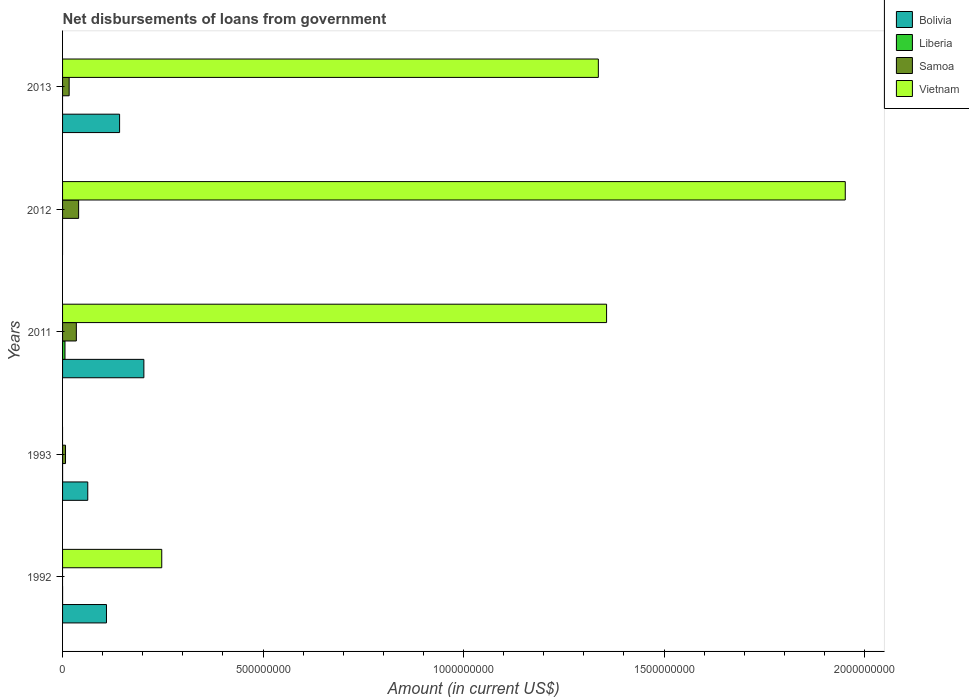How many different coloured bars are there?
Offer a terse response. 4. How many groups of bars are there?
Your answer should be very brief. 5. How many bars are there on the 4th tick from the top?
Give a very brief answer. 3. What is the label of the 1st group of bars from the top?
Your answer should be compact. 2013. What is the amount of loan disbursed from government in Bolivia in 2013?
Offer a very short reply. 1.42e+08. Across all years, what is the maximum amount of loan disbursed from government in Samoa?
Your answer should be very brief. 4.00e+07. What is the total amount of loan disbursed from government in Liberia in the graph?
Offer a very short reply. 6.09e+06. What is the difference between the amount of loan disbursed from government in Bolivia in 1993 and that in 2013?
Your answer should be compact. -7.93e+07. What is the difference between the amount of loan disbursed from government in Vietnam in 1992 and the amount of loan disbursed from government in Bolivia in 2013?
Provide a succinct answer. 1.05e+08. What is the average amount of loan disbursed from government in Bolivia per year?
Your answer should be very brief. 1.03e+08. In the year 2011, what is the difference between the amount of loan disbursed from government in Vietnam and amount of loan disbursed from government in Bolivia?
Your answer should be very brief. 1.15e+09. In how many years, is the amount of loan disbursed from government in Bolivia greater than 1300000000 US$?
Your answer should be very brief. 0. What is the ratio of the amount of loan disbursed from government in Samoa in 2011 to that in 2013?
Your answer should be compact. 2.09. What is the difference between the highest and the second highest amount of loan disbursed from government in Bolivia?
Make the answer very short. 6.06e+07. What is the difference between the highest and the lowest amount of loan disbursed from government in Vietnam?
Your response must be concise. 1.95e+09. In how many years, is the amount of loan disbursed from government in Vietnam greater than the average amount of loan disbursed from government in Vietnam taken over all years?
Give a very brief answer. 3. Is it the case that in every year, the sum of the amount of loan disbursed from government in Liberia and amount of loan disbursed from government in Vietnam is greater than the amount of loan disbursed from government in Bolivia?
Provide a succinct answer. No. Are all the bars in the graph horizontal?
Keep it short and to the point. Yes. How many years are there in the graph?
Offer a terse response. 5. Does the graph contain grids?
Offer a terse response. No. How many legend labels are there?
Ensure brevity in your answer.  4. How are the legend labels stacked?
Your response must be concise. Vertical. What is the title of the graph?
Your response must be concise. Net disbursements of loans from government. Does "Latin America(all income levels)" appear as one of the legend labels in the graph?
Give a very brief answer. No. What is the label or title of the X-axis?
Ensure brevity in your answer.  Amount (in current US$). What is the Amount (in current US$) of Bolivia in 1992?
Provide a succinct answer. 1.09e+08. What is the Amount (in current US$) in Liberia in 1992?
Keep it short and to the point. 2.70e+04. What is the Amount (in current US$) of Samoa in 1992?
Your response must be concise. 0. What is the Amount (in current US$) in Vietnam in 1992?
Offer a terse response. 2.47e+08. What is the Amount (in current US$) of Bolivia in 1993?
Provide a succinct answer. 6.29e+07. What is the Amount (in current US$) in Liberia in 1993?
Your response must be concise. 2.50e+04. What is the Amount (in current US$) of Samoa in 1993?
Keep it short and to the point. 7.37e+06. What is the Amount (in current US$) in Vietnam in 1993?
Provide a succinct answer. 0. What is the Amount (in current US$) of Bolivia in 2011?
Your answer should be very brief. 2.03e+08. What is the Amount (in current US$) in Liberia in 2011?
Your response must be concise. 6.04e+06. What is the Amount (in current US$) of Samoa in 2011?
Your answer should be very brief. 3.44e+07. What is the Amount (in current US$) of Vietnam in 2011?
Offer a very short reply. 1.36e+09. What is the Amount (in current US$) in Bolivia in 2012?
Make the answer very short. 0. What is the Amount (in current US$) in Liberia in 2012?
Your response must be concise. 0. What is the Amount (in current US$) in Samoa in 2012?
Your answer should be compact. 4.00e+07. What is the Amount (in current US$) of Vietnam in 2012?
Your answer should be very brief. 1.95e+09. What is the Amount (in current US$) of Bolivia in 2013?
Ensure brevity in your answer.  1.42e+08. What is the Amount (in current US$) in Samoa in 2013?
Offer a very short reply. 1.65e+07. What is the Amount (in current US$) in Vietnam in 2013?
Offer a very short reply. 1.34e+09. Across all years, what is the maximum Amount (in current US$) of Bolivia?
Make the answer very short. 2.03e+08. Across all years, what is the maximum Amount (in current US$) in Liberia?
Provide a short and direct response. 6.04e+06. Across all years, what is the maximum Amount (in current US$) of Samoa?
Your answer should be very brief. 4.00e+07. Across all years, what is the maximum Amount (in current US$) of Vietnam?
Your answer should be compact. 1.95e+09. Across all years, what is the minimum Amount (in current US$) of Liberia?
Make the answer very short. 0. What is the total Amount (in current US$) of Bolivia in the graph?
Ensure brevity in your answer.  5.17e+08. What is the total Amount (in current US$) of Liberia in the graph?
Keep it short and to the point. 6.09e+06. What is the total Amount (in current US$) in Samoa in the graph?
Make the answer very short. 9.82e+07. What is the total Amount (in current US$) of Vietnam in the graph?
Keep it short and to the point. 4.89e+09. What is the difference between the Amount (in current US$) in Bolivia in 1992 and that in 1993?
Give a very brief answer. 4.66e+07. What is the difference between the Amount (in current US$) in Liberia in 1992 and that in 1993?
Your answer should be very brief. 2000. What is the difference between the Amount (in current US$) in Bolivia in 1992 and that in 2011?
Your response must be concise. -9.33e+07. What is the difference between the Amount (in current US$) in Liberia in 1992 and that in 2011?
Your answer should be compact. -6.01e+06. What is the difference between the Amount (in current US$) of Vietnam in 1992 and that in 2011?
Keep it short and to the point. -1.11e+09. What is the difference between the Amount (in current US$) of Vietnam in 1992 and that in 2012?
Offer a terse response. -1.70e+09. What is the difference between the Amount (in current US$) of Bolivia in 1992 and that in 2013?
Your answer should be very brief. -3.27e+07. What is the difference between the Amount (in current US$) of Vietnam in 1992 and that in 2013?
Make the answer very short. -1.09e+09. What is the difference between the Amount (in current US$) of Bolivia in 1993 and that in 2011?
Offer a very short reply. -1.40e+08. What is the difference between the Amount (in current US$) of Liberia in 1993 and that in 2011?
Keep it short and to the point. -6.02e+06. What is the difference between the Amount (in current US$) in Samoa in 1993 and that in 2011?
Your response must be concise. -2.70e+07. What is the difference between the Amount (in current US$) of Samoa in 1993 and that in 2012?
Your answer should be very brief. -3.27e+07. What is the difference between the Amount (in current US$) in Bolivia in 1993 and that in 2013?
Your answer should be very brief. -7.93e+07. What is the difference between the Amount (in current US$) of Samoa in 1993 and that in 2013?
Provide a short and direct response. -9.08e+06. What is the difference between the Amount (in current US$) in Samoa in 2011 and that in 2012?
Keep it short and to the point. -5.66e+06. What is the difference between the Amount (in current US$) of Vietnam in 2011 and that in 2012?
Offer a terse response. -5.95e+08. What is the difference between the Amount (in current US$) in Bolivia in 2011 and that in 2013?
Make the answer very short. 6.06e+07. What is the difference between the Amount (in current US$) of Samoa in 2011 and that in 2013?
Your answer should be compact. 1.79e+07. What is the difference between the Amount (in current US$) in Vietnam in 2011 and that in 2013?
Keep it short and to the point. 2.06e+07. What is the difference between the Amount (in current US$) in Samoa in 2012 and that in 2013?
Provide a succinct answer. 2.36e+07. What is the difference between the Amount (in current US$) of Vietnam in 2012 and that in 2013?
Ensure brevity in your answer.  6.16e+08. What is the difference between the Amount (in current US$) in Bolivia in 1992 and the Amount (in current US$) in Liberia in 1993?
Offer a very short reply. 1.09e+08. What is the difference between the Amount (in current US$) of Bolivia in 1992 and the Amount (in current US$) of Samoa in 1993?
Provide a short and direct response. 1.02e+08. What is the difference between the Amount (in current US$) of Liberia in 1992 and the Amount (in current US$) of Samoa in 1993?
Give a very brief answer. -7.35e+06. What is the difference between the Amount (in current US$) in Bolivia in 1992 and the Amount (in current US$) in Liberia in 2011?
Your answer should be very brief. 1.03e+08. What is the difference between the Amount (in current US$) of Bolivia in 1992 and the Amount (in current US$) of Samoa in 2011?
Your response must be concise. 7.51e+07. What is the difference between the Amount (in current US$) of Bolivia in 1992 and the Amount (in current US$) of Vietnam in 2011?
Make the answer very short. -1.25e+09. What is the difference between the Amount (in current US$) in Liberia in 1992 and the Amount (in current US$) in Samoa in 2011?
Offer a very short reply. -3.43e+07. What is the difference between the Amount (in current US$) of Liberia in 1992 and the Amount (in current US$) of Vietnam in 2011?
Offer a very short reply. -1.36e+09. What is the difference between the Amount (in current US$) of Bolivia in 1992 and the Amount (in current US$) of Samoa in 2012?
Ensure brevity in your answer.  6.95e+07. What is the difference between the Amount (in current US$) of Bolivia in 1992 and the Amount (in current US$) of Vietnam in 2012?
Offer a very short reply. -1.84e+09. What is the difference between the Amount (in current US$) of Liberia in 1992 and the Amount (in current US$) of Samoa in 2012?
Offer a very short reply. -4.00e+07. What is the difference between the Amount (in current US$) in Liberia in 1992 and the Amount (in current US$) in Vietnam in 2012?
Your answer should be very brief. -1.95e+09. What is the difference between the Amount (in current US$) of Bolivia in 1992 and the Amount (in current US$) of Samoa in 2013?
Provide a succinct answer. 9.30e+07. What is the difference between the Amount (in current US$) of Bolivia in 1992 and the Amount (in current US$) of Vietnam in 2013?
Your answer should be compact. -1.23e+09. What is the difference between the Amount (in current US$) in Liberia in 1992 and the Amount (in current US$) in Samoa in 2013?
Give a very brief answer. -1.64e+07. What is the difference between the Amount (in current US$) in Liberia in 1992 and the Amount (in current US$) in Vietnam in 2013?
Your response must be concise. -1.34e+09. What is the difference between the Amount (in current US$) of Bolivia in 1993 and the Amount (in current US$) of Liberia in 2011?
Offer a very short reply. 5.68e+07. What is the difference between the Amount (in current US$) of Bolivia in 1993 and the Amount (in current US$) of Samoa in 2011?
Your answer should be compact. 2.85e+07. What is the difference between the Amount (in current US$) of Bolivia in 1993 and the Amount (in current US$) of Vietnam in 2011?
Keep it short and to the point. -1.29e+09. What is the difference between the Amount (in current US$) of Liberia in 1993 and the Amount (in current US$) of Samoa in 2011?
Make the answer very short. -3.43e+07. What is the difference between the Amount (in current US$) in Liberia in 1993 and the Amount (in current US$) in Vietnam in 2011?
Your response must be concise. -1.36e+09. What is the difference between the Amount (in current US$) in Samoa in 1993 and the Amount (in current US$) in Vietnam in 2011?
Your response must be concise. -1.35e+09. What is the difference between the Amount (in current US$) of Bolivia in 1993 and the Amount (in current US$) of Samoa in 2012?
Offer a terse response. 2.28e+07. What is the difference between the Amount (in current US$) in Bolivia in 1993 and the Amount (in current US$) in Vietnam in 2012?
Offer a terse response. -1.89e+09. What is the difference between the Amount (in current US$) in Liberia in 1993 and the Amount (in current US$) in Samoa in 2012?
Give a very brief answer. -4.00e+07. What is the difference between the Amount (in current US$) in Liberia in 1993 and the Amount (in current US$) in Vietnam in 2012?
Your answer should be very brief. -1.95e+09. What is the difference between the Amount (in current US$) in Samoa in 1993 and the Amount (in current US$) in Vietnam in 2012?
Ensure brevity in your answer.  -1.94e+09. What is the difference between the Amount (in current US$) of Bolivia in 1993 and the Amount (in current US$) of Samoa in 2013?
Offer a very short reply. 4.64e+07. What is the difference between the Amount (in current US$) in Bolivia in 1993 and the Amount (in current US$) in Vietnam in 2013?
Ensure brevity in your answer.  -1.27e+09. What is the difference between the Amount (in current US$) of Liberia in 1993 and the Amount (in current US$) of Samoa in 2013?
Provide a short and direct response. -1.64e+07. What is the difference between the Amount (in current US$) of Liberia in 1993 and the Amount (in current US$) of Vietnam in 2013?
Keep it short and to the point. -1.34e+09. What is the difference between the Amount (in current US$) in Samoa in 1993 and the Amount (in current US$) in Vietnam in 2013?
Make the answer very short. -1.33e+09. What is the difference between the Amount (in current US$) of Bolivia in 2011 and the Amount (in current US$) of Samoa in 2012?
Provide a short and direct response. 1.63e+08. What is the difference between the Amount (in current US$) of Bolivia in 2011 and the Amount (in current US$) of Vietnam in 2012?
Offer a very short reply. -1.75e+09. What is the difference between the Amount (in current US$) of Liberia in 2011 and the Amount (in current US$) of Samoa in 2012?
Keep it short and to the point. -3.40e+07. What is the difference between the Amount (in current US$) in Liberia in 2011 and the Amount (in current US$) in Vietnam in 2012?
Provide a succinct answer. -1.95e+09. What is the difference between the Amount (in current US$) in Samoa in 2011 and the Amount (in current US$) in Vietnam in 2012?
Your answer should be very brief. -1.92e+09. What is the difference between the Amount (in current US$) of Bolivia in 2011 and the Amount (in current US$) of Samoa in 2013?
Your answer should be very brief. 1.86e+08. What is the difference between the Amount (in current US$) in Bolivia in 2011 and the Amount (in current US$) in Vietnam in 2013?
Your response must be concise. -1.13e+09. What is the difference between the Amount (in current US$) of Liberia in 2011 and the Amount (in current US$) of Samoa in 2013?
Your answer should be very brief. -1.04e+07. What is the difference between the Amount (in current US$) in Liberia in 2011 and the Amount (in current US$) in Vietnam in 2013?
Your answer should be compact. -1.33e+09. What is the difference between the Amount (in current US$) of Samoa in 2011 and the Amount (in current US$) of Vietnam in 2013?
Give a very brief answer. -1.30e+09. What is the difference between the Amount (in current US$) of Samoa in 2012 and the Amount (in current US$) of Vietnam in 2013?
Make the answer very short. -1.30e+09. What is the average Amount (in current US$) in Bolivia per year?
Provide a short and direct response. 1.03e+08. What is the average Amount (in current US$) of Liberia per year?
Make the answer very short. 1.22e+06. What is the average Amount (in current US$) of Samoa per year?
Provide a succinct answer. 1.96e+07. What is the average Amount (in current US$) of Vietnam per year?
Offer a very short reply. 9.78e+08. In the year 1992, what is the difference between the Amount (in current US$) of Bolivia and Amount (in current US$) of Liberia?
Your answer should be very brief. 1.09e+08. In the year 1992, what is the difference between the Amount (in current US$) of Bolivia and Amount (in current US$) of Vietnam?
Your answer should be compact. -1.38e+08. In the year 1992, what is the difference between the Amount (in current US$) of Liberia and Amount (in current US$) of Vietnam?
Provide a short and direct response. -2.47e+08. In the year 1993, what is the difference between the Amount (in current US$) in Bolivia and Amount (in current US$) in Liberia?
Give a very brief answer. 6.28e+07. In the year 1993, what is the difference between the Amount (in current US$) of Bolivia and Amount (in current US$) of Samoa?
Offer a very short reply. 5.55e+07. In the year 1993, what is the difference between the Amount (in current US$) in Liberia and Amount (in current US$) in Samoa?
Provide a short and direct response. -7.35e+06. In the year 2011, what is the difference between the Amount (in current US$) of Bolivia and Amount (in current US$) of Liberia?
Provide a short and direct response. 1.97e+08. In the year 2011, what is the difference between the Amount (in current US$) of Bolivia and Amount (in current US$) of Samoa?
Your answer should be compact. 1.68e+08. In the year 2011, what is the difference between the Amount (in current US$) in Bolivia and Amount (in current US$) in Vietnam?
Provide a succinct answer. -1.15e+09. In the year 2011, what is the difference between the Amount (in current US$) in Liberia and Amount (in current US$) in Samoa?
Keep it short and to the point. -2.83e+07. In the year 2011, what is the difference between the Amount (in current US$) in Liberia and Amount (in current US$) in Vietnam?
Ensure brevity in your answer.  -1.35e+09. In the year 2011, what is the difference between the Amount (in current US$) of Samoa and Amount (in current US$) of Vietnam?
Offer a very short reply. -1.32e+09. In the year 2012, what is the difference between the Amount (in current US$) of Samoa and Amount (in current US$) of Vietnam?
Your answer should be very brief. -1.91e+09. In the year 2013, what is the difference between the Amount (in current US$) in Bolivia and Amount (in current US$) in Samoa?
Make the answer very short. 1.26e+08. In the year 2013, what is the difference between the Amount (in current US$) of Bolivia and Amount (in current US$) of Vietnam?
Provide a short and direct response. -1.19e+09. In the year 2013, what is the difference between the Amount (in current US$) in Samoa and Amount (in current US$) in Vietnam?
Ensure brevity in your answer.  -1.32e+09. What is the ratio of the Amount (in current US$) in Bolivia in 1992 to that in 1993?
Your response must be concise. 1.74. What is the ratio of the Amount (in current US$) of Liberia in 1992 to that in 1993?
Keep it short and to the point. 1.08. What is the ratio of the Amount (in current US$) of Bolivia in 1992 to that in 2011?
Provide a succinct answer. 0.54. What is the ratio of the Amount (in current US$) in Liberia in 1992 to that in 2011?
Your answer should be very brief. 0. What is the ratio of the Amount (in current US$) in Vietnam in 1992 to that in 2011?
Provide a succinct answer. 0.18. What is the ratio of the Amount (in current US$) of Vietnam in 1992 to that in 2012?
Give a very brief answer. 0.13. What is the ratio of the Amount (in current US$) in Bolivia in 1992 to that in 2013?
Offer a very short reply. 0.77. What is the ratio of the Amount (in current US$) of Vietnam in 1992 to that in 2013?
Your answer should be very brief. 0.19. What is the ratio of the Amount (in current US$) of Bolivia in 1993 to that in 2011?
Make the answer very short. 0.31. What is the ratio of the Amount (in current US$) of Liberia in 1993 to that in 2011?
Give a very brief answer. 0. What is the ratio of the Amount (in current US$) of Samoa in 1993 to that in 2011?
Give a very brief answer. 0.21. What is the ratio of the Amount (in current US$) of Samoa in 1993 to that in 2012?
Provide a short and direct response. 0.18. What is the ratio of the Amount (in current US$) in Bolivia in 1993 to that in 2013?
Your response must be concise. 0.44. What is the ratio of the Amount (in current US$) in Samoa in 1993 to that in 2013?
Make the answer very short. 0.45. What is the ratio of the Amount (in current US$) of Samoa in 2011 to that in 2012?
Provide a short and direct response. 0.86. What is the ratio of the Amount (in current US$) in Vietnam in 2011 to that in 2012?
Your answer should be compact. 0.7. What is the ratio of the Amount (in current US$) of Bolivia in 2011 to that in 2013?
Give a very brief answer. 1.43. What is the ratio of the Amount (in current US$) of Samoa in 2011 to that in 2013?
Make the answer very short. 2.09. What is the ratio of the Amount (in current US$) of Vietnam in 2011 to that in 2013?
Ensure brevity in your answer.  1.02. What is the ratio of the Amount (in current US$) of Samoa in 2012 to that in 2013?
Your answer should be very brief. 2.43. What is the ratio of the Amount (in current US$) in Vietnam in 2012 to that in 2013?
Provide a short and direct response. 1.46. What is the difference between the highest and the second highest Amount (in current US$) in Bolivia?
Make the answer very short. 6.06e+07. What is the difference between the highest and the second highest Amount (in current US$) of Liberia?
Your response must be concise. 6.01e+06. What is the difference between the highest and the second highest Amount (in current US$) of Samoa?
Give a very brief answer. 5.66e+06. What is the difference between the highest and the second highest Amount (in current US$) of Vietnam?
Your answer should be very brief. 5.95e+08. What is the difference between the highest and the lowest Amount (in current US$) in Bolivia?
Offer a terse response. 2.03e+08. What is the difference between the highest and the lowest Amount (in current US$) in Liberia?
Make the answer very short. 6.04e+06. What is the difference between the highest and the lowest Amount (in current US$) in Samoa?
Provide a succinct answer. 4.00e+07. What is the difference between the highest and the lowest Amount (in current US$) in Vietnam?
Provide a succinct answer. 1.95e+09. 